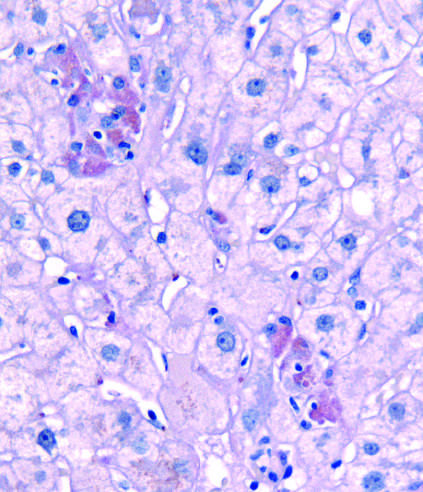what does pas-d, periodic acid-schiff stain after?
Answer the question using a single word or phrase. Diastase digestion 